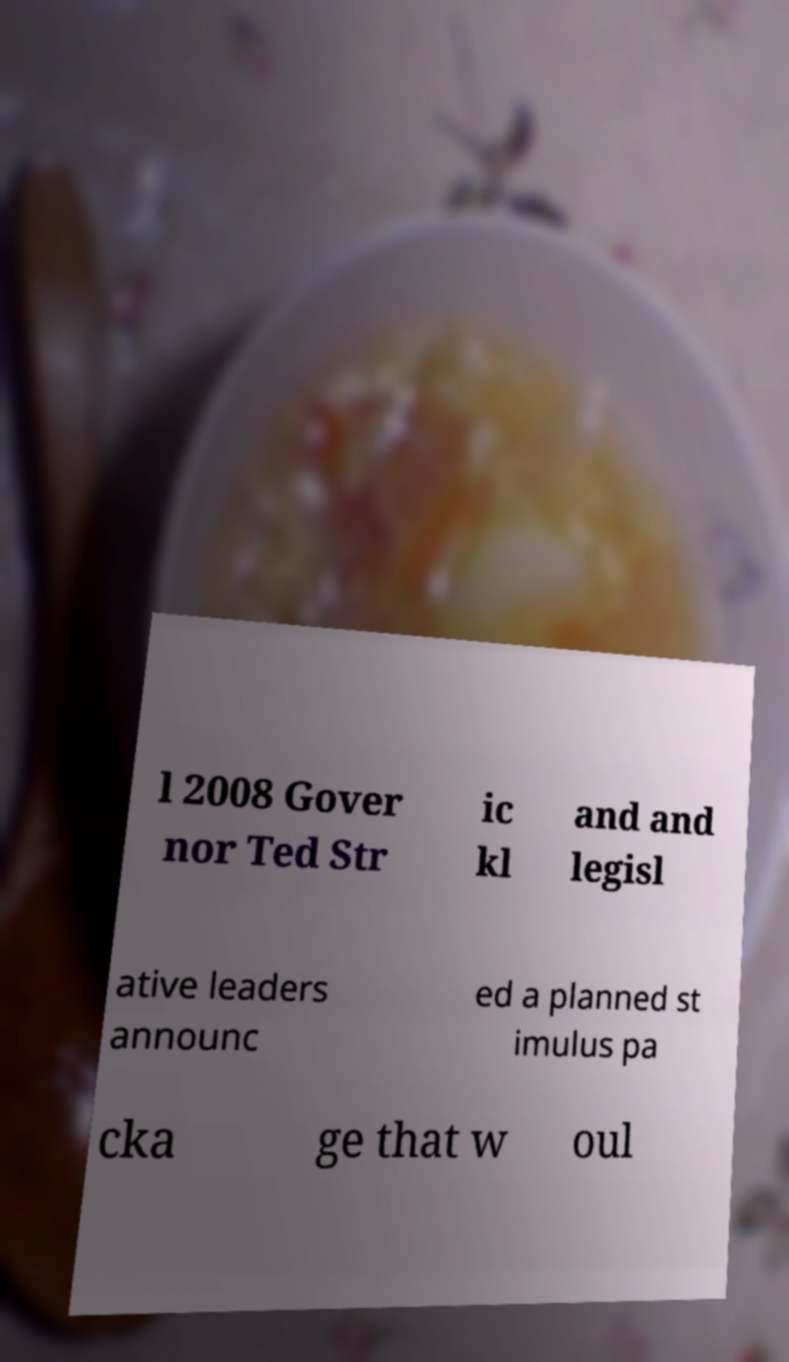Please identify and transcribe the text found in this image. l 2008 Gover nor Ted Str ic kl and and legisl ative leaders announc ed a planned st imulus pa cka ge that w oul 